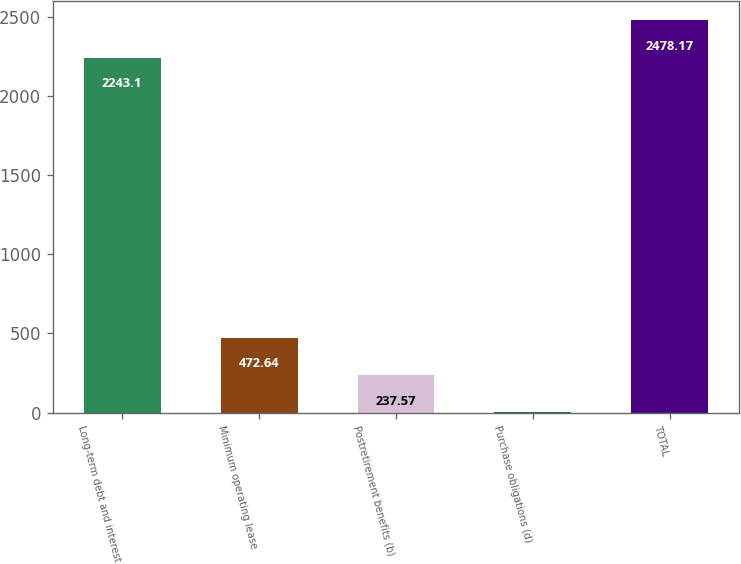Convert chart. <chart><loc_0><loc_0><loc_500><loc_500><bar_chart><fcel>Long-term debt and interest<fcel>Minimum operating lease<fcel>Postretirement benefits (b)<fcel>Purchase obligations (d)<fcel>TOTAL<nl><fcel>2243.1<fcel>472.64<fcel>237.57<fcel>2.5<fcel>2478.17<nl></chart> 